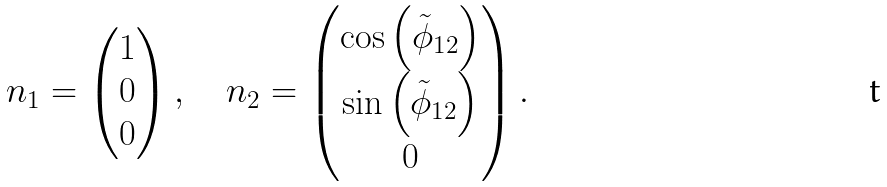Convert formula to latex. <formula><loc_0><loc_0><loc_500><loc_500>n _ { 1 } = \begin{pmatrix} 1 \\ 0 \\ 0 \end{pmatrix} , \quad n _ { 2 } = \begin{pmatrix} \cos \left ( \tilde { \phi } _ { 1 2 } \right ) \\ \sin \left ( \tilde { \phi } _ { 1 2 } \right ) \\ 0 \end{pmatrix} .</formula> 